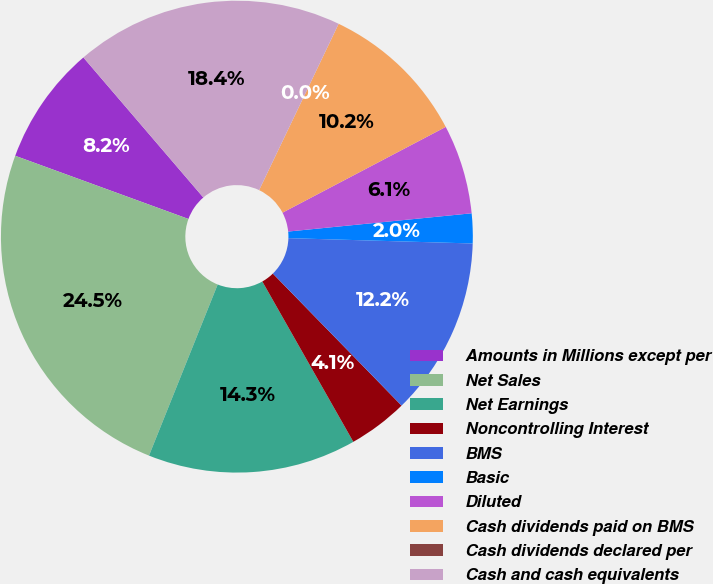Convert chart. <chart><loc_0><loc_0><loc_500><loc_500><pie_chart><fcel>Amounts in Millions except per<fcel>Net Sales<fcel>Net Earnings<fcel>Noncontrolling Interest<fcel>BMS<fcel>Basic<fcel>Diluted<fcel>Cash dividends paid on BMS<fcel>Cash dividends declared per<fcel>Cash and cash equivalents<nl><fcel>8.16%<fcel>24.49%<fcel>14.29%<fcel>4.08%<fcel>12.24%<fcel>2.04%<fcel>6.12%<fcel>10.2%<fcel>0.0%<fcel>18.37%<nl></chart> 